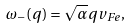<formula> <loc_0><loc_0><loc_500><loc_500>\omega _ { - } ( q ) = \sqrt { \alpha } q v _ { F e } ,</formula> 